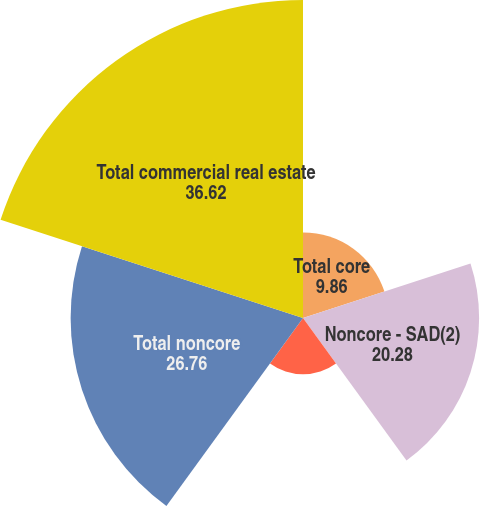Convert chart. <chart><loc_0><loc_0><loc_500><loc_500><pie_chart><fcel>Total core<fcel>Noncore - SAD(2)<fcel>Noncore - Other<fcel>Total noncore<fcel>Total commercial real estate<nl><fcel>9.86%<fcel>20.28%<fcel>6.47%<fcel>26.76%<fcel>36.62%<nl></chart> 